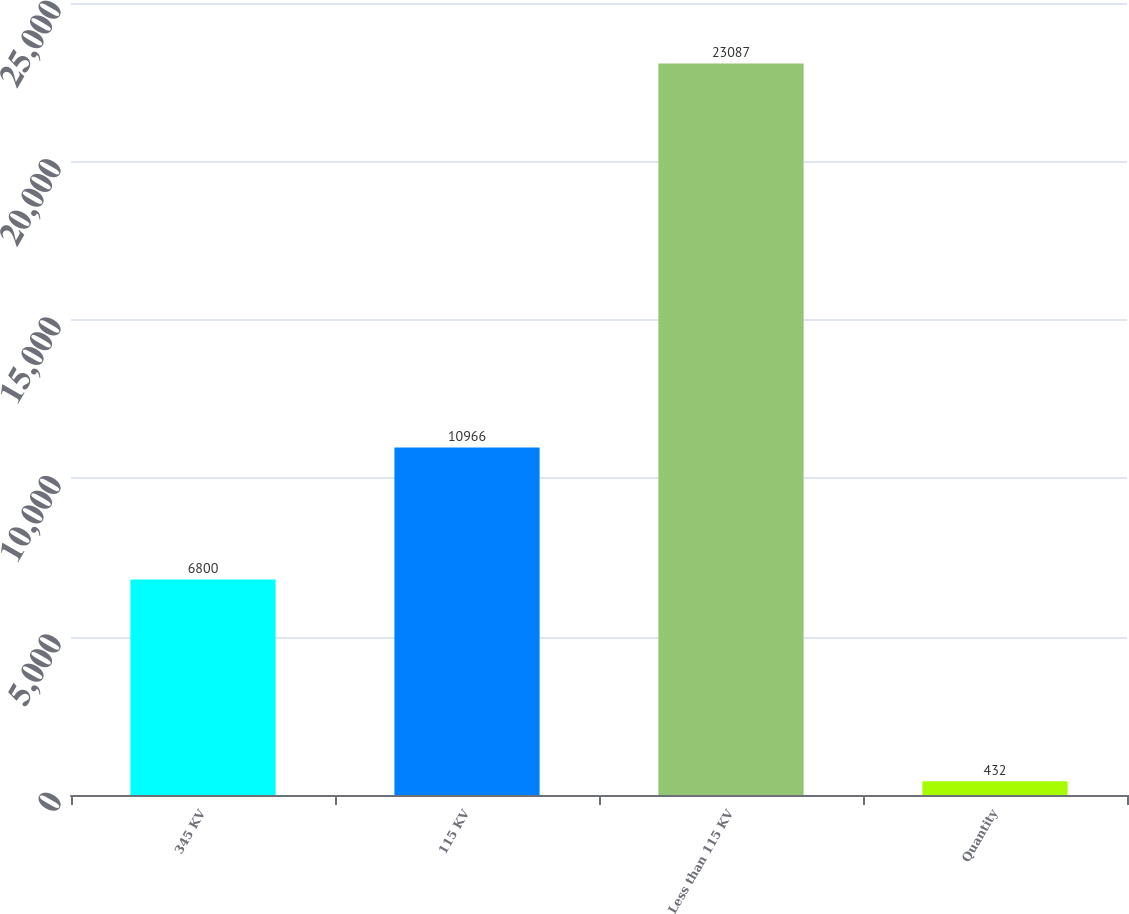Convert chart to OTSL. <chart><loc_0><loc_0><loc_500><loc_500><bar_chart><fcel>345 KV<fcel>115 KV<fcel>Less than 115 KV<fcel>Quantity<nl><fcel>6800<fcel>10966<fcel>23087<fcel>432<nl></chart> 